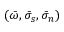<formula> <loc_0><loc_0><loc_500><loc_500>( \bar { \omega } , \bar { \sigma } _ { s } , \bar { \sigma } _ { n } )</formula> 